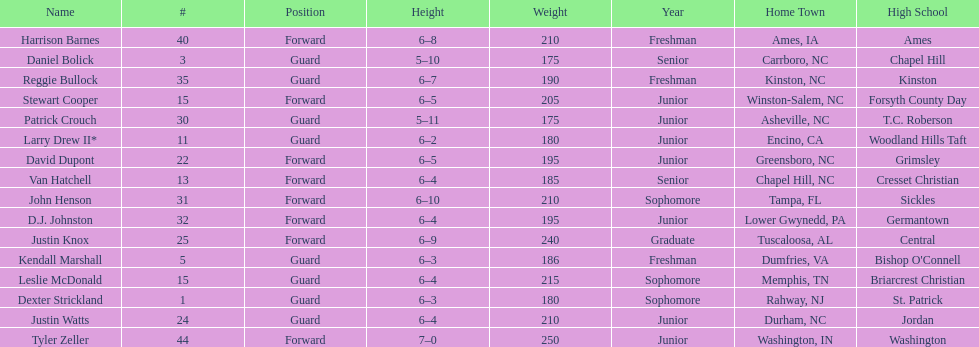How many individuals play in non-guard positions? 8. 